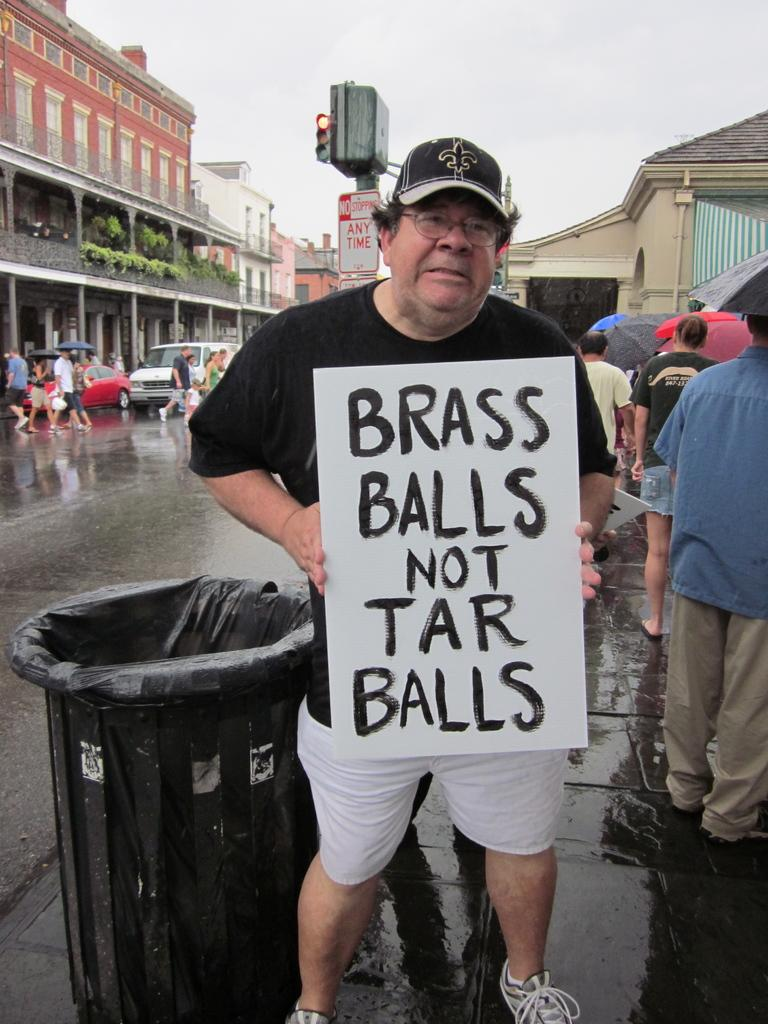<image>
Write a terse but informative summary of the picture. A male stands holding a sign saying Brass Balls not Tar Balls. 